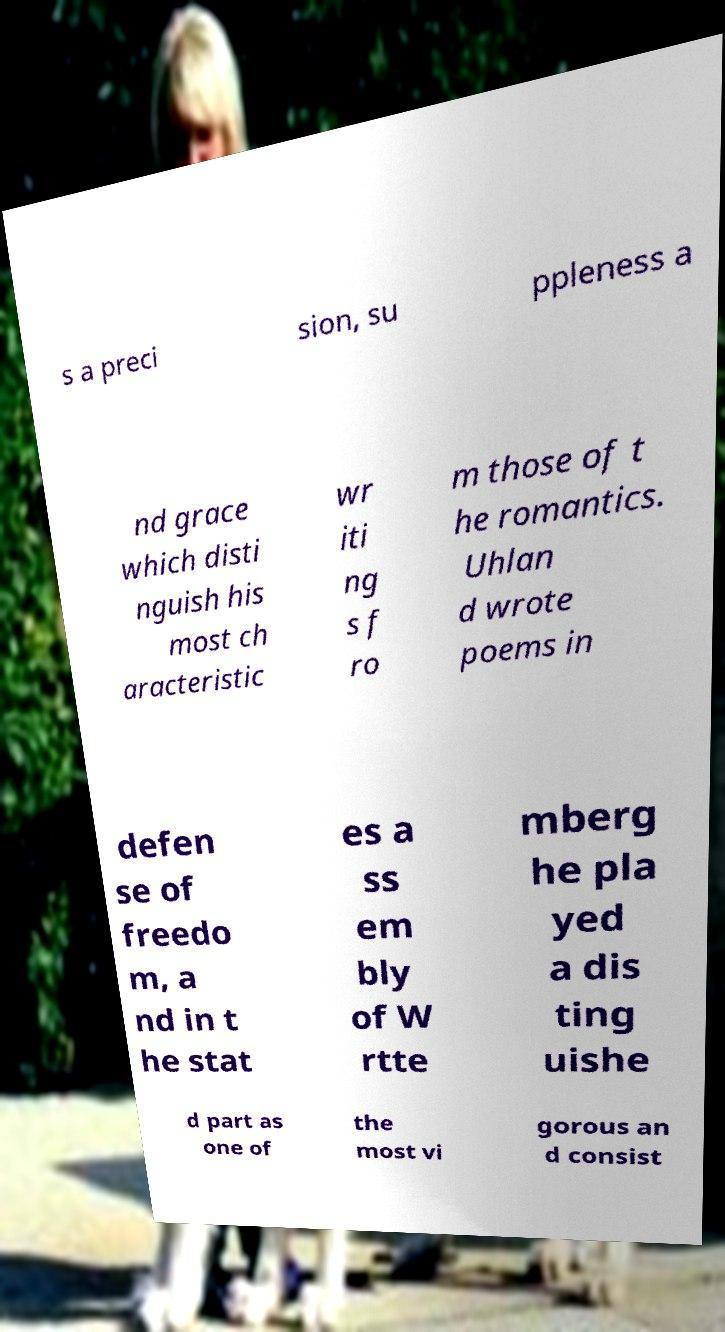What messages or text are displayed in this image? I need them in a readable, typed format. s a preci sion, su ppleness a nd grace which disti nguish his most ch aracteristic wr iti ng s f ro m those of t he romantics. Uhlan d wrote poems in defen se of freedo m, a nd in t he stat es a ss em bly of W rtte mberg he pla yed a dis ting uishe d part as one of the most vi gorous an d consist 